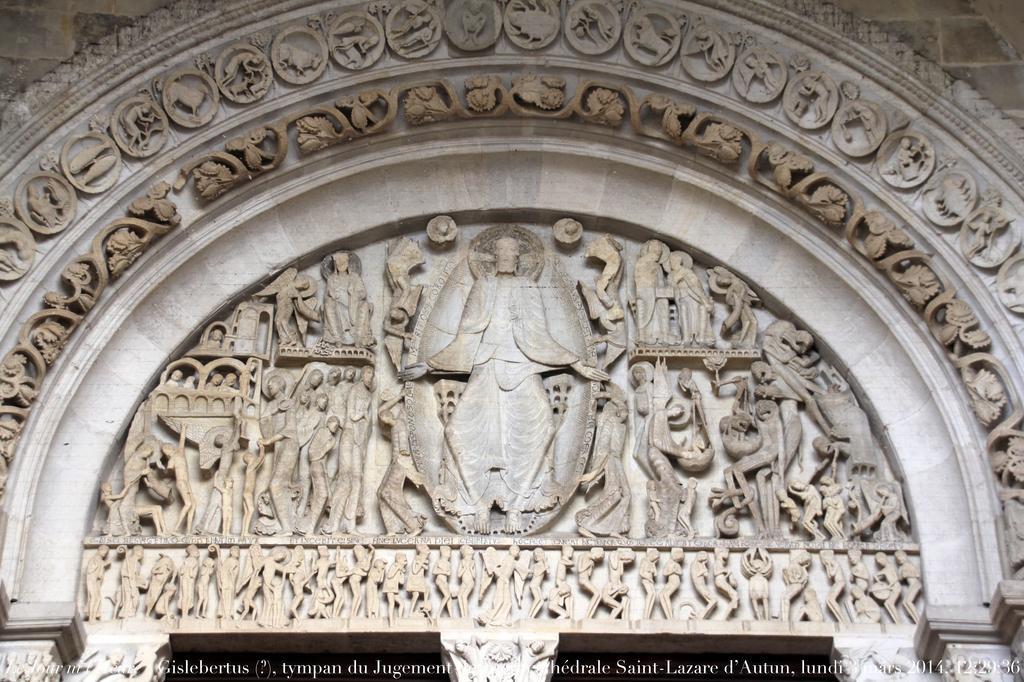Could you give a brief overview of what you see in this image? In this picture we can see sculptures, at the bottom there is some text. 